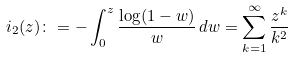Convert formula to latex. <formula><loc_0><loc_0><loc_500><loc_500>\L i _ { 2 } ( z ) \colon = - \int _ { 0 } ^ { z } \frac { \log ( 1 - w ) } { w } \, d w = \sum _ { k = 1 } ^ { \infty } \frac { z ^ { k } } { k ^ { 2 } }</formula> 